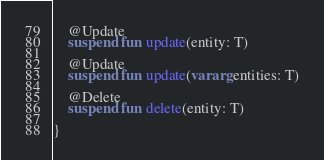<code> <loc_0><loc_0><loc_500><loc_500><_Kotlin_>    @Update
    suspend fun update(entity: T)

    @Update
    suspend fun update(vararg entities: T)

    @Delete
    suspend fun delete(entity: T)

}</code> 